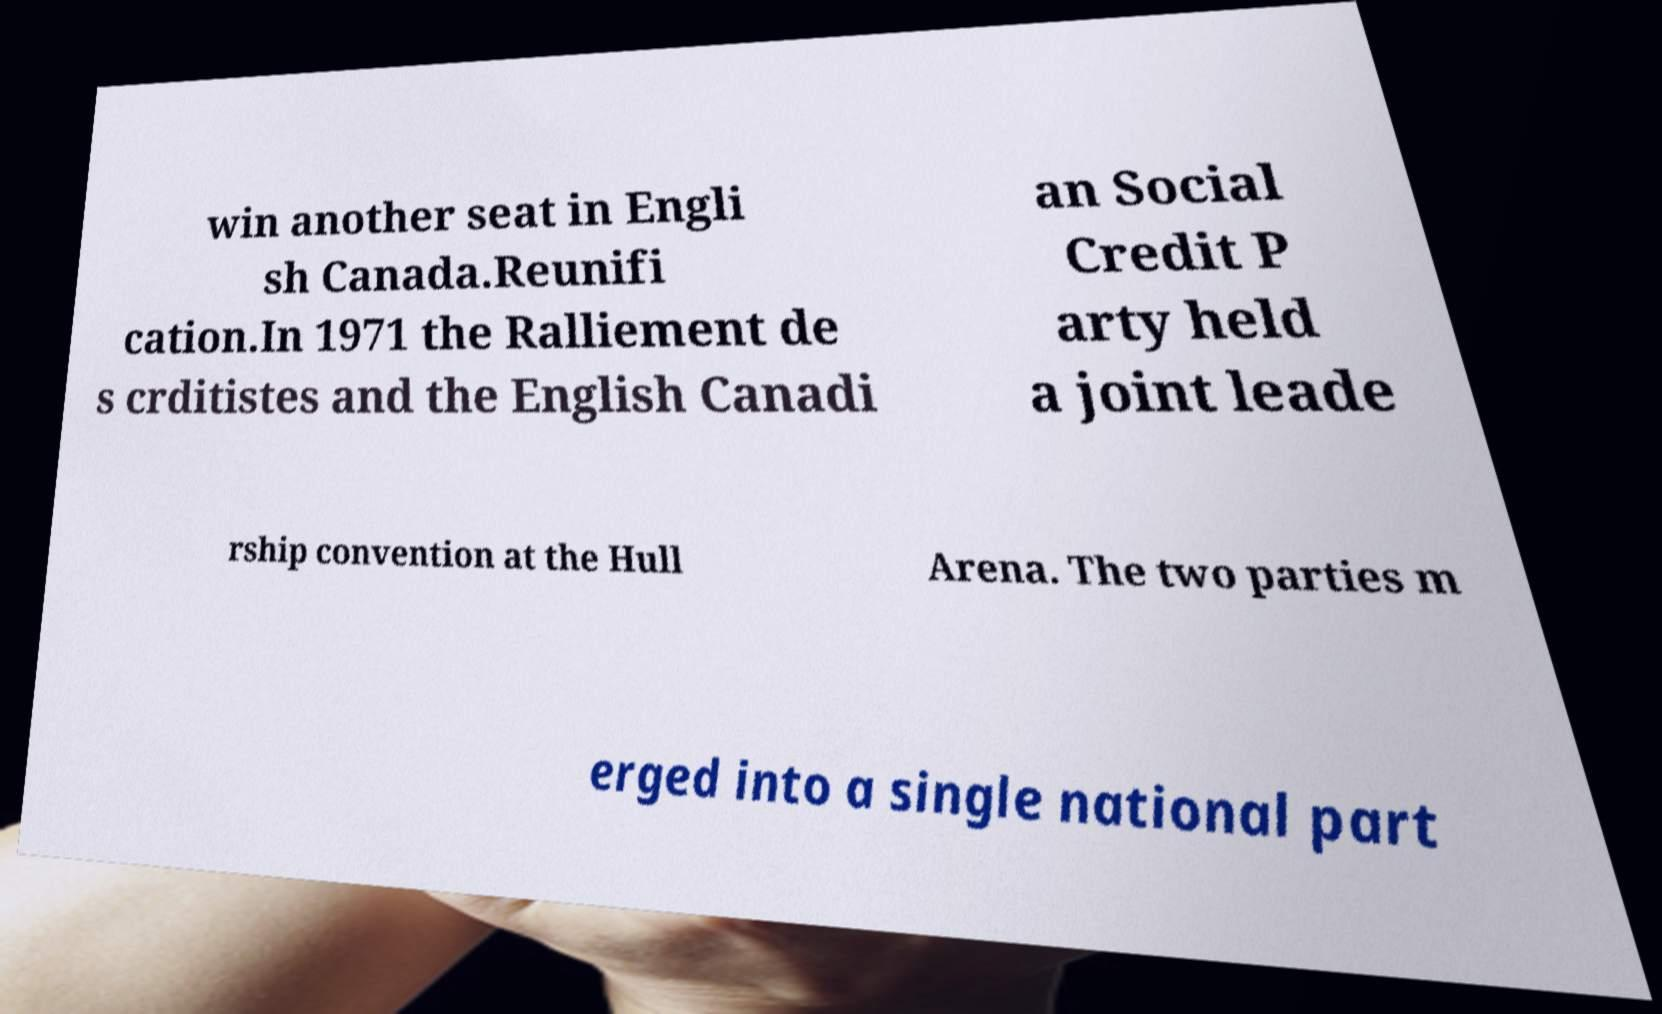Please read and relay the text visible in this image. What does it say? win another seat in Engli sh Canada.Reunifi cation.In 1971 the Ralliement de s crditistes and the English Canadi an Social Credit P arty held a joint leade rship convention at the Hull Arena. The two parties m erged into a single national part 